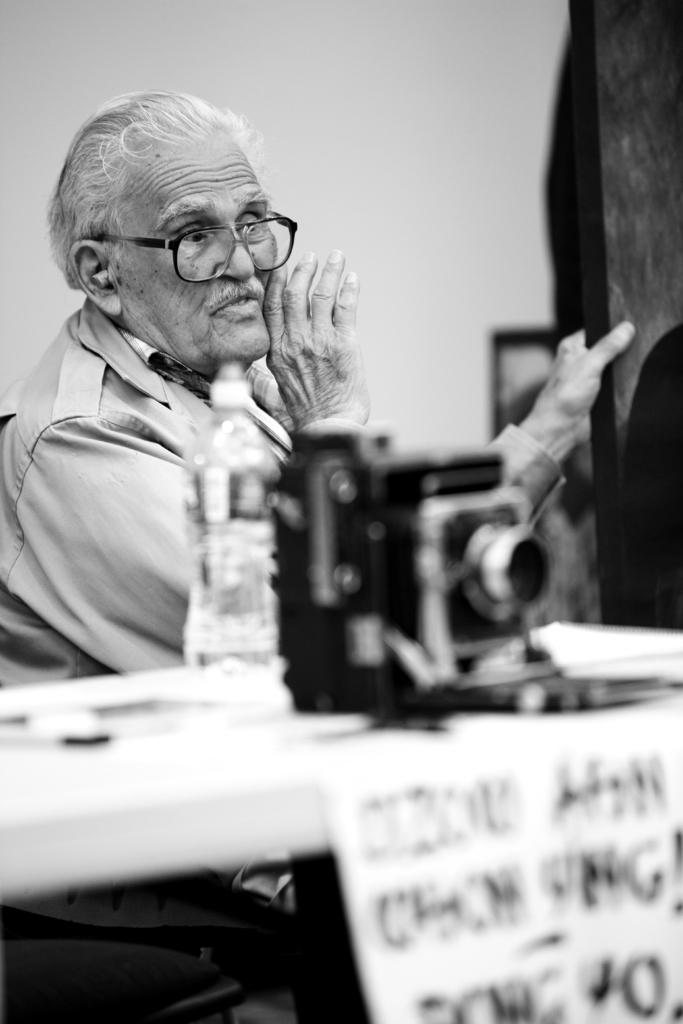What is the main object in the image? There is a camera in the image. What else can be seen in the image besides the camera? There is a bottle and objects on the table in the image. Is there anyone present in the image? Yes, there is a person sitting in the background. How is the image presented? The image is in black and white. What type of work does the owner of the camera do in the image? There is no information about the owner of the camera in the image, so we cannot determine their occupation. 